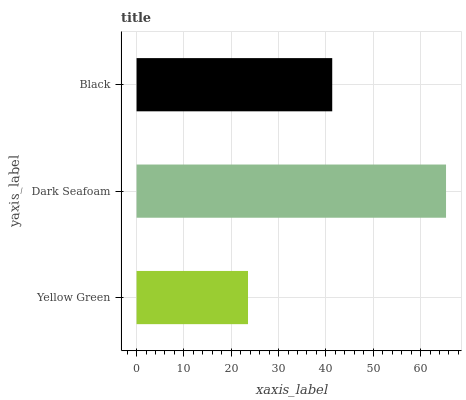Is Yellow Green the minimum?
Answer yes or no. Yes. Is Dark Seafoam the maximum?
Answer yes or no. Yes. Is Black the minimum?
Answer yes or no. No. Is Black the maximum?
Answer yes or no. No. Is Dark Seafoam greater than Black?
Answer yes or no. Yes. Is Black less than Dark Seafoam?
Answer yes or no. Yes. Is Black greater than Dark Seafoam?
Answer yes or no. No. Is Dark Seafoam less than Black?
Answer yes or no. No. Is Black the high median?
Answer yes or no. Yes. Is Black the low median?
Answer yes or no. Yes. Is Yellow Green the high median?
Answer yes or no. No. Is Dark Seafoam the low median?
Answer yes or no. No. 